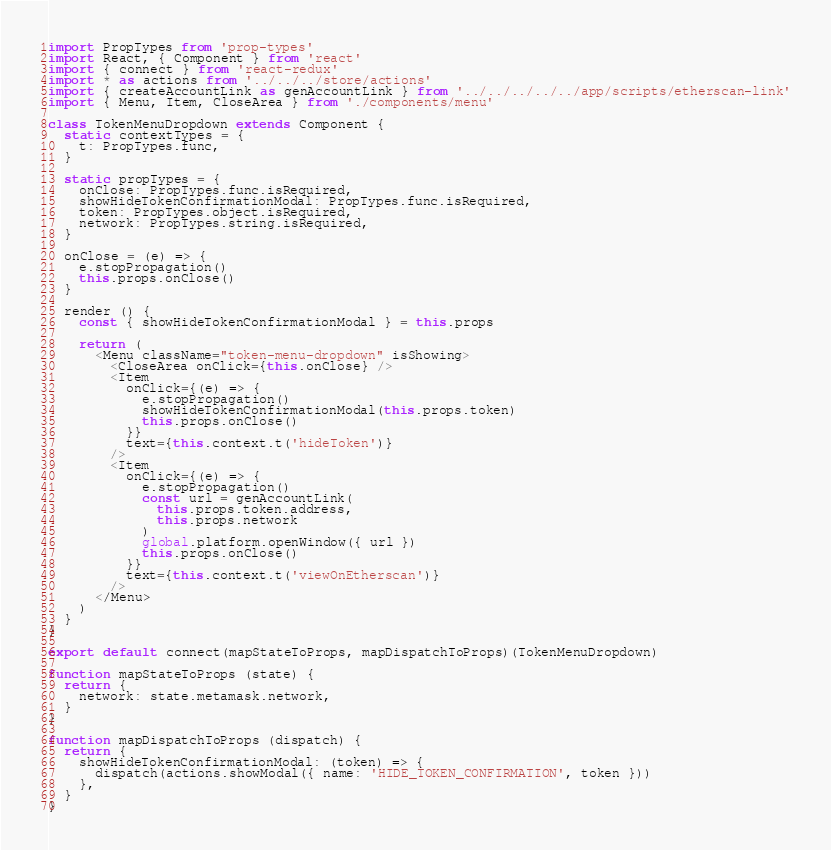<code> <loc_0><loc_0><loc_500><loc_500><_JavaScript_>import PropTypes from 'prop-types'
import React, { Component } from 'react'
import { connect } from 'react-redux'
import * as actions from '../../../store/actions'
import { createAccountLink as genAccountLink } from '../../../../../app/scripts/etherscan-link'
import { Menu, Item, CloseArea } from './components/menu'

class TokenMenuDropdown extends Component {
  static contextTypes = {
    t: PropTypes.func,
  }

  static propTypes = {
    onClose: PropTypes.func.isRequired,
    showHideTokenConfirmationModal: PropTypes.func.isRequired,
    token: PropTypes.object.isRequired,
    network: PropTypes.string.isRequired,
  }

  onClose = (e) => {
    e.stopPropagation()
    this.props.onClose()
  }

  render () {
    const { showHideTokenConfirmationModal } = this.props

    return (
      <Menu className="token-menu-dropdown" isShowing>
        <CloseArea onClick={this.onClose} />
        <Item
          onClick={(e) => {
            e.stopPropagation()
            showHideTokenConfirmationModal(this.props.token)
            this.props.onClose()
          }}
          text={this.context.t('hideToken')}
        />
        <Item
          onClick={(e) => {
            e.stopPropagation()
            const url = genAccountLink(
              this.props.token.address,
              this.props.network
            )
            global.platform.openWindow({ url })
            this.props.onClose()
          }}
          text={this.context.t('viewOnEtherscan')}
        />
      </Menu>
    )
  }
}

export default connect(mapStateToProps, mapDispatchToProps)(TokenMenuDropdown)

function mapStateToProps (state) {
  return {
    network: state.metamask.network,
  }
}

function mapDispatchToProps (dispatch) {
  return {
    showHideTokenConfirmationModal: (token) => {
      dispatch(actions.showModal({ name: 'HIDE_TOKEN_CONFIRMATION', token }))
    },
  }
}
</code> 